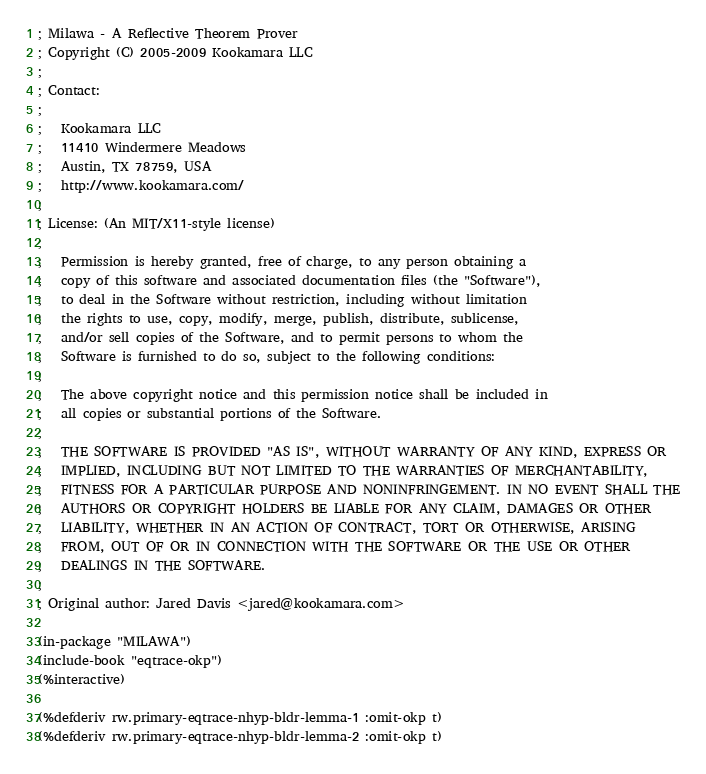<code> <loc_0><loc_0><loc_500><loc_500><_Lisp_>; Milawa - A Reflective Theorem Prover
; Copyright (C) 2005-2009 Kookamara LLC
;
; Contact:
;
;   Kookamara LLC
;   11410 Windermere Meadows
;   Austin, TX 78759, USA
;   http://www.kookamara.com/
;
; License: (An MIT/X11-style license)
;
;   Permission is hereby granted, free of charge, to any person obtaining a
;   copy of this software and associated documentation files (the "Software"),
;   to deal in the Software without restriction, including without limitation
;   the rights to use, copy, modify, merge, publish, distribute, sublicense,
;   and/or sell copies of the Software, and to permit persons to whom the
;   Software is furnished to do so, subject to the following conditions:
;
;   The above copyright notice and this permission notice shall be included in
;   all copies or substantial portions of the Software.
;
;   THE SOFTWARE IS PROVIDED "AS IS", WITHOUT WARRANTY OF ANY KIND, EXPRESS OR
;   IMPLIED, INCLUDING BUT NOT LIMITED TO THE WARRANTIES OF MERCHANTABILITY,
;   FITNESS FOR A PARTICULAR PURPOSE AND NONINFRINGEMENT. IN NO EVENT SHALL THE
;   AUTHORS OR COPYRIGHT HOLDERS BE LIABLE FOR ANY CLAIM, DAMAGES OR OTHER
;   LIABILITY, WHETHER IN AN ACTION OF CONTRACT, TORT OR OTHERWISE, ARISING
;   FROM, OUT OF OR IN CONNECTION WITH THE SOFTWARE OR THE USE OR OTHER
;   DEALINGS IN THE SOFTWARE.
;
; Original author: Jared Davis <jared@kookamara.com>

(in-package "MILAWA")
(include-book "eqtrace-okp")
(%interactive)

(%defderiv rw.primary-eqtrace-nhyp-bldr-lemma-1 :omit-okp t)
(%defderiv rw.primary-eqtrace-nhyp-bldr-lemma-2 :omit-okp t)
</code> 